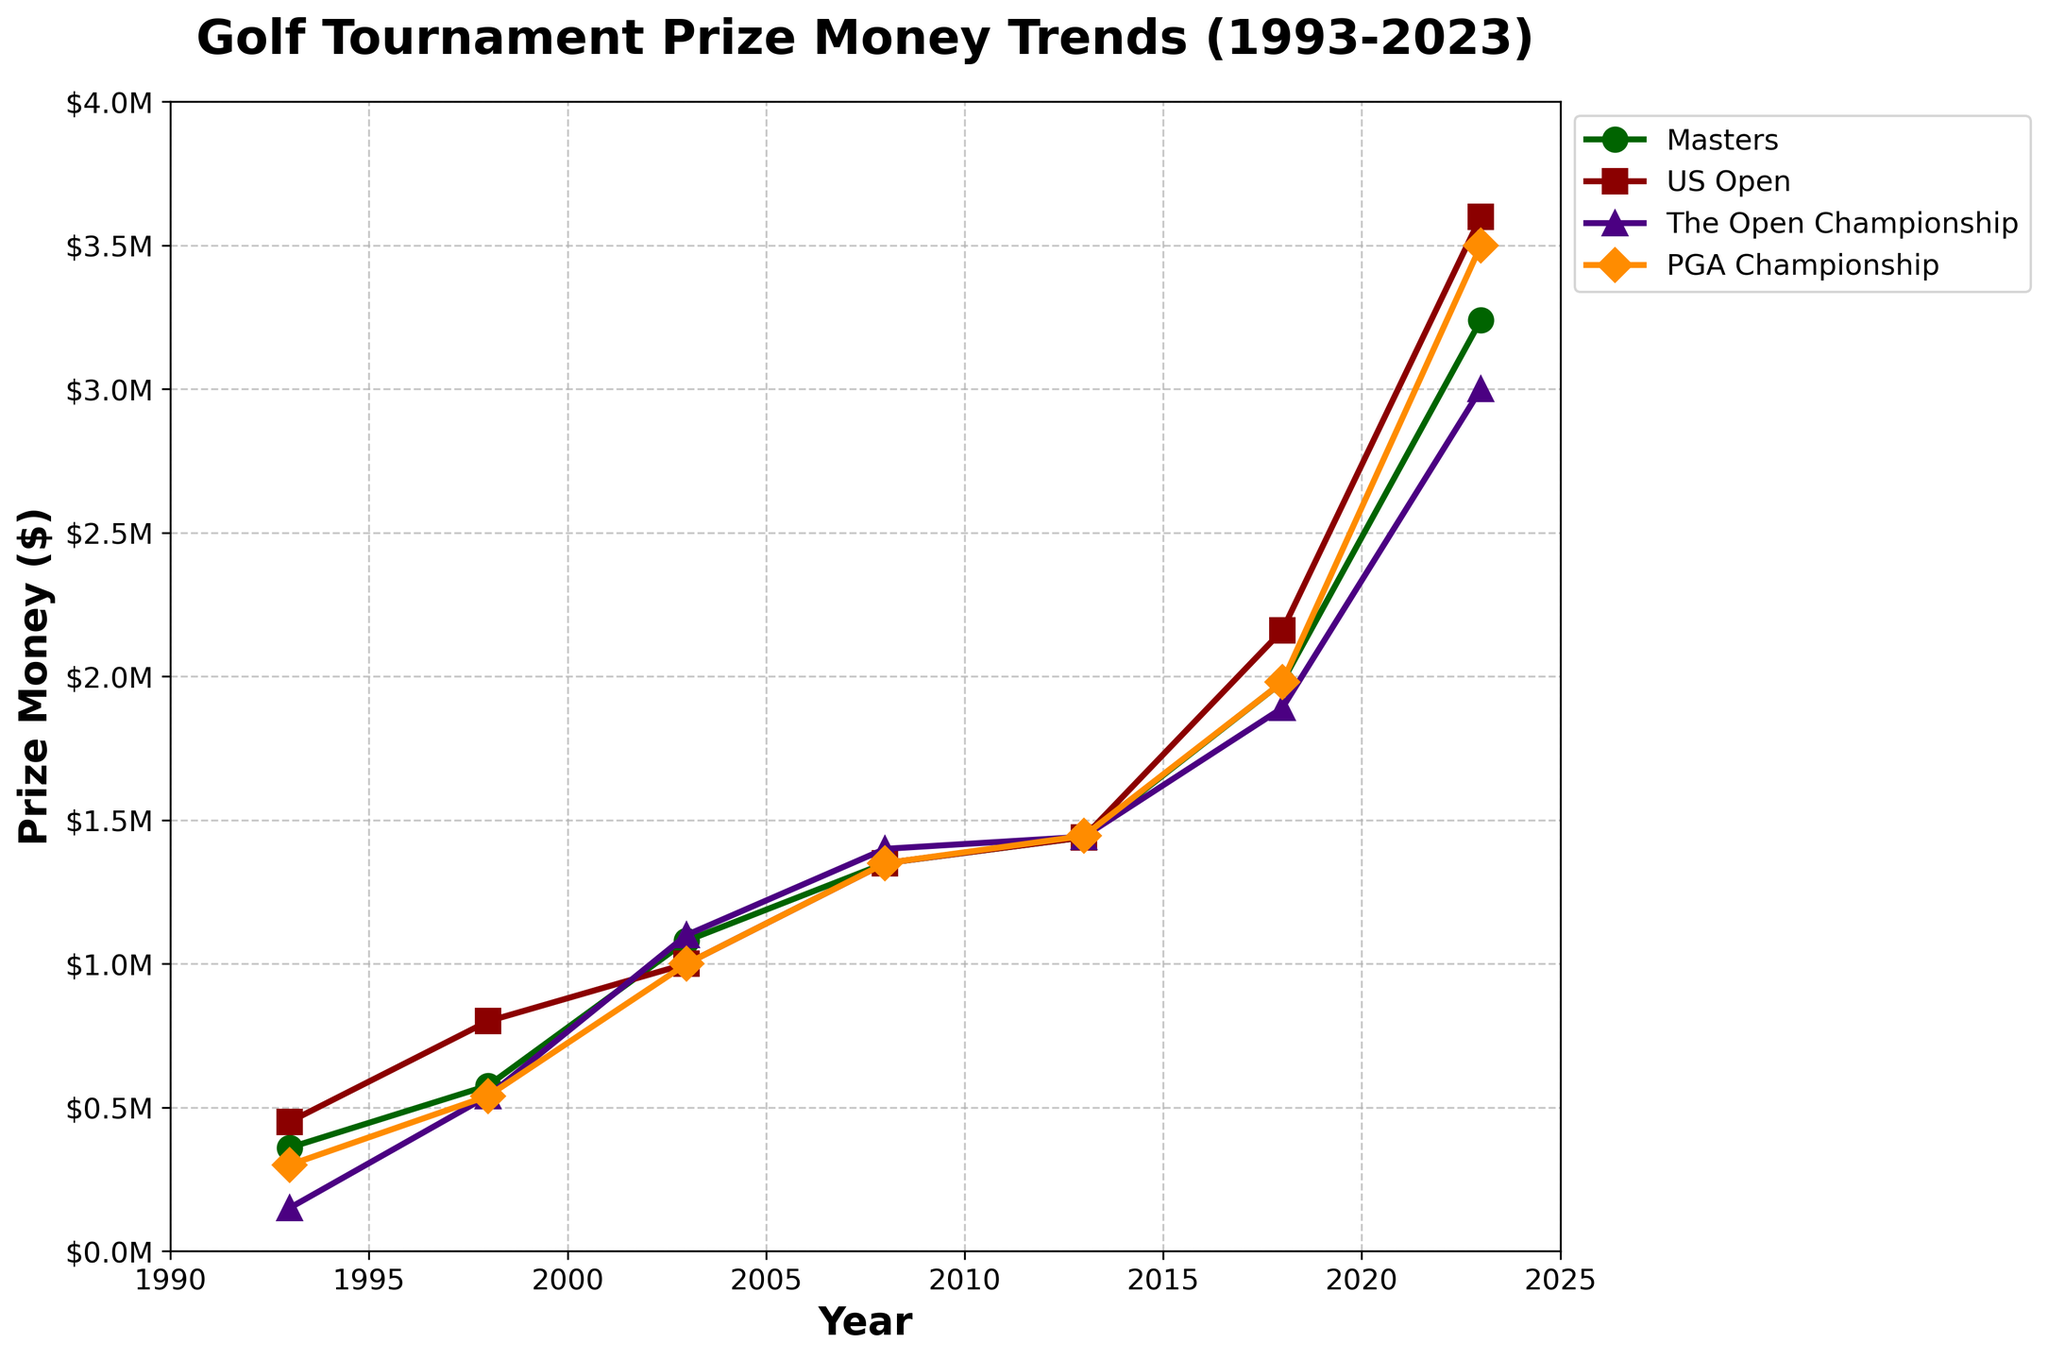What was the prize money for the Masters Tournament in 2003? We can locate the point on the graph where the line representing the Masters Tournament intersects with the year 2003 on the x-axis. The corresponding y-value for that point will give us the prize money.
Answer: $1,080,000 How much did the prize money for the US Open increase from 1993 to 2023? First, find the prize money for the US Open in 1993 and 2023. In 1993, it was $450,000, and in 2023, it was $3,600,000. The increase is calculated by subtracting the 1993 value from the 2023 value: $3,600,000 - $450,000.
Answer: $3,150,000 In which year was the prize money for The Open Championship the highest? Look for the peak point on the line representing The Open Championship. The year corresponding to the highest point on this line will indicate when the prize money was the highest.
Answer: 2023 Which tournament had the smallest prize money in 1998? Compare the y-values for all four tournaments at the point corresponding to 1998 on the x-axis. The tournament with the lowest y-value will have the smallest prize money.
Answer: The Open Championship By how much did the prize money for the PGA Championship differ between 2008 and 2013? Find the prize money for the PGA Championship in 2008 ($1,350,000) and in 2013 ($1,445,000). Calculate the difference by subtracting the 2008 value from the 2013 value: $1,445,000 - $1,350,000.
Answer: $95,000 Which tournament shows the most significant overall trend in increasing prize money from 1993 to 2023? Observe all the lines on the chart and compare their overall upward trends. Identify the tournament with the steepest increase.
Answer: US Open How did the prize money for all tournaments combine in 2003? Sum the prize money for all tournaments in the year 2003: Masters ($1,080,000) + US Open ($1,000,000) + The Open Championship ($1,100,000) + PGA Championship ($1,000,000).
Answer: $4,180,000 Which year saw the Masters Tournament's prize money reach $1,980,000? Locate the point on the line representing the Masters Tournament where the y-value matches $1,980,000, then identify the corresponding year on the x-axis.
Answer: 2018 Has any tournament's prize money ever surpassed $3,500,000? Check the y-axis values for each tournament and see if any lines go above the $3,500,000 mark.
Answer: Yes 